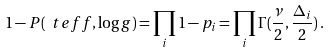Convert formula to latex. <formula><loc_0><loc_0><loc_500><loc_500>1 - P ( \ t e f f , \log g ) = \prod _ { i } 1 - p _ { i } = \prod _ { i } \Gamma ( \frac { \nu } { 2 } , \frac { \Delta _ { i } } { 2 } ) \, .</formula> 